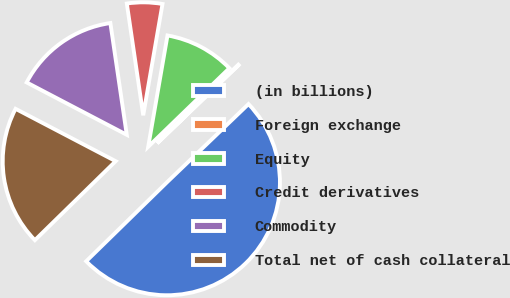Convert chart. <chart><loc_0><loc_0><loc_500><loc_500><pie_chart><fcel>(in billions)<fcel>Foreign exchange<fcel>Equity<fcel>Credit derivatives<fcel>Commodity<fcel>Total net of cash collateral<nl><fcel>49.85%<fcel>0.07%<fcel>10.03%<fcel>5.05%<fcel>15.01%<fcel>19.99%<nl></chart> 